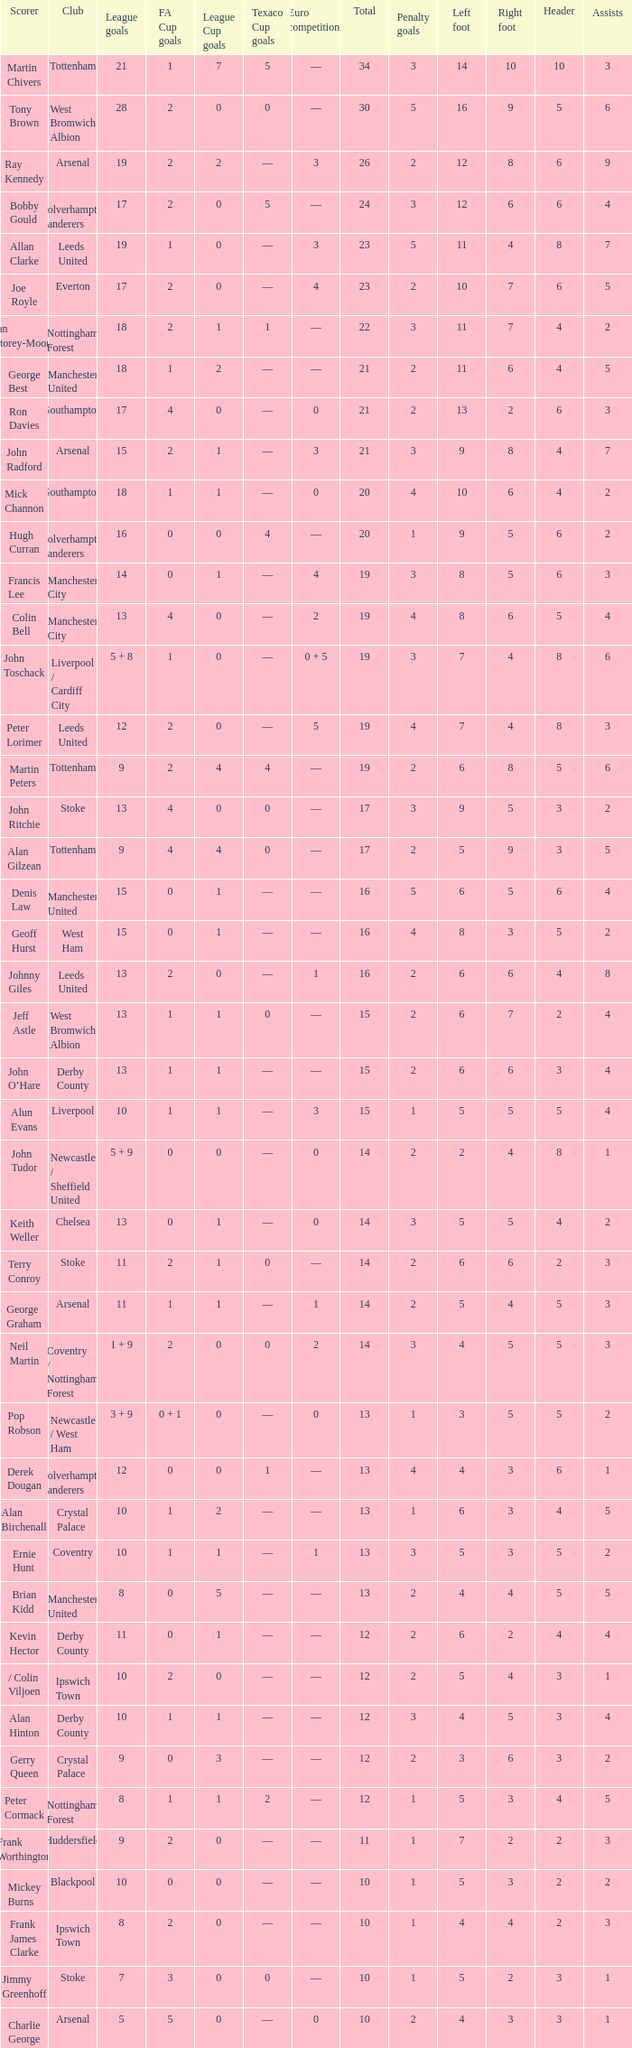What is FA Cup Goals, when Euro Competitions is 1, and when League Goals is 11? 1.0. 